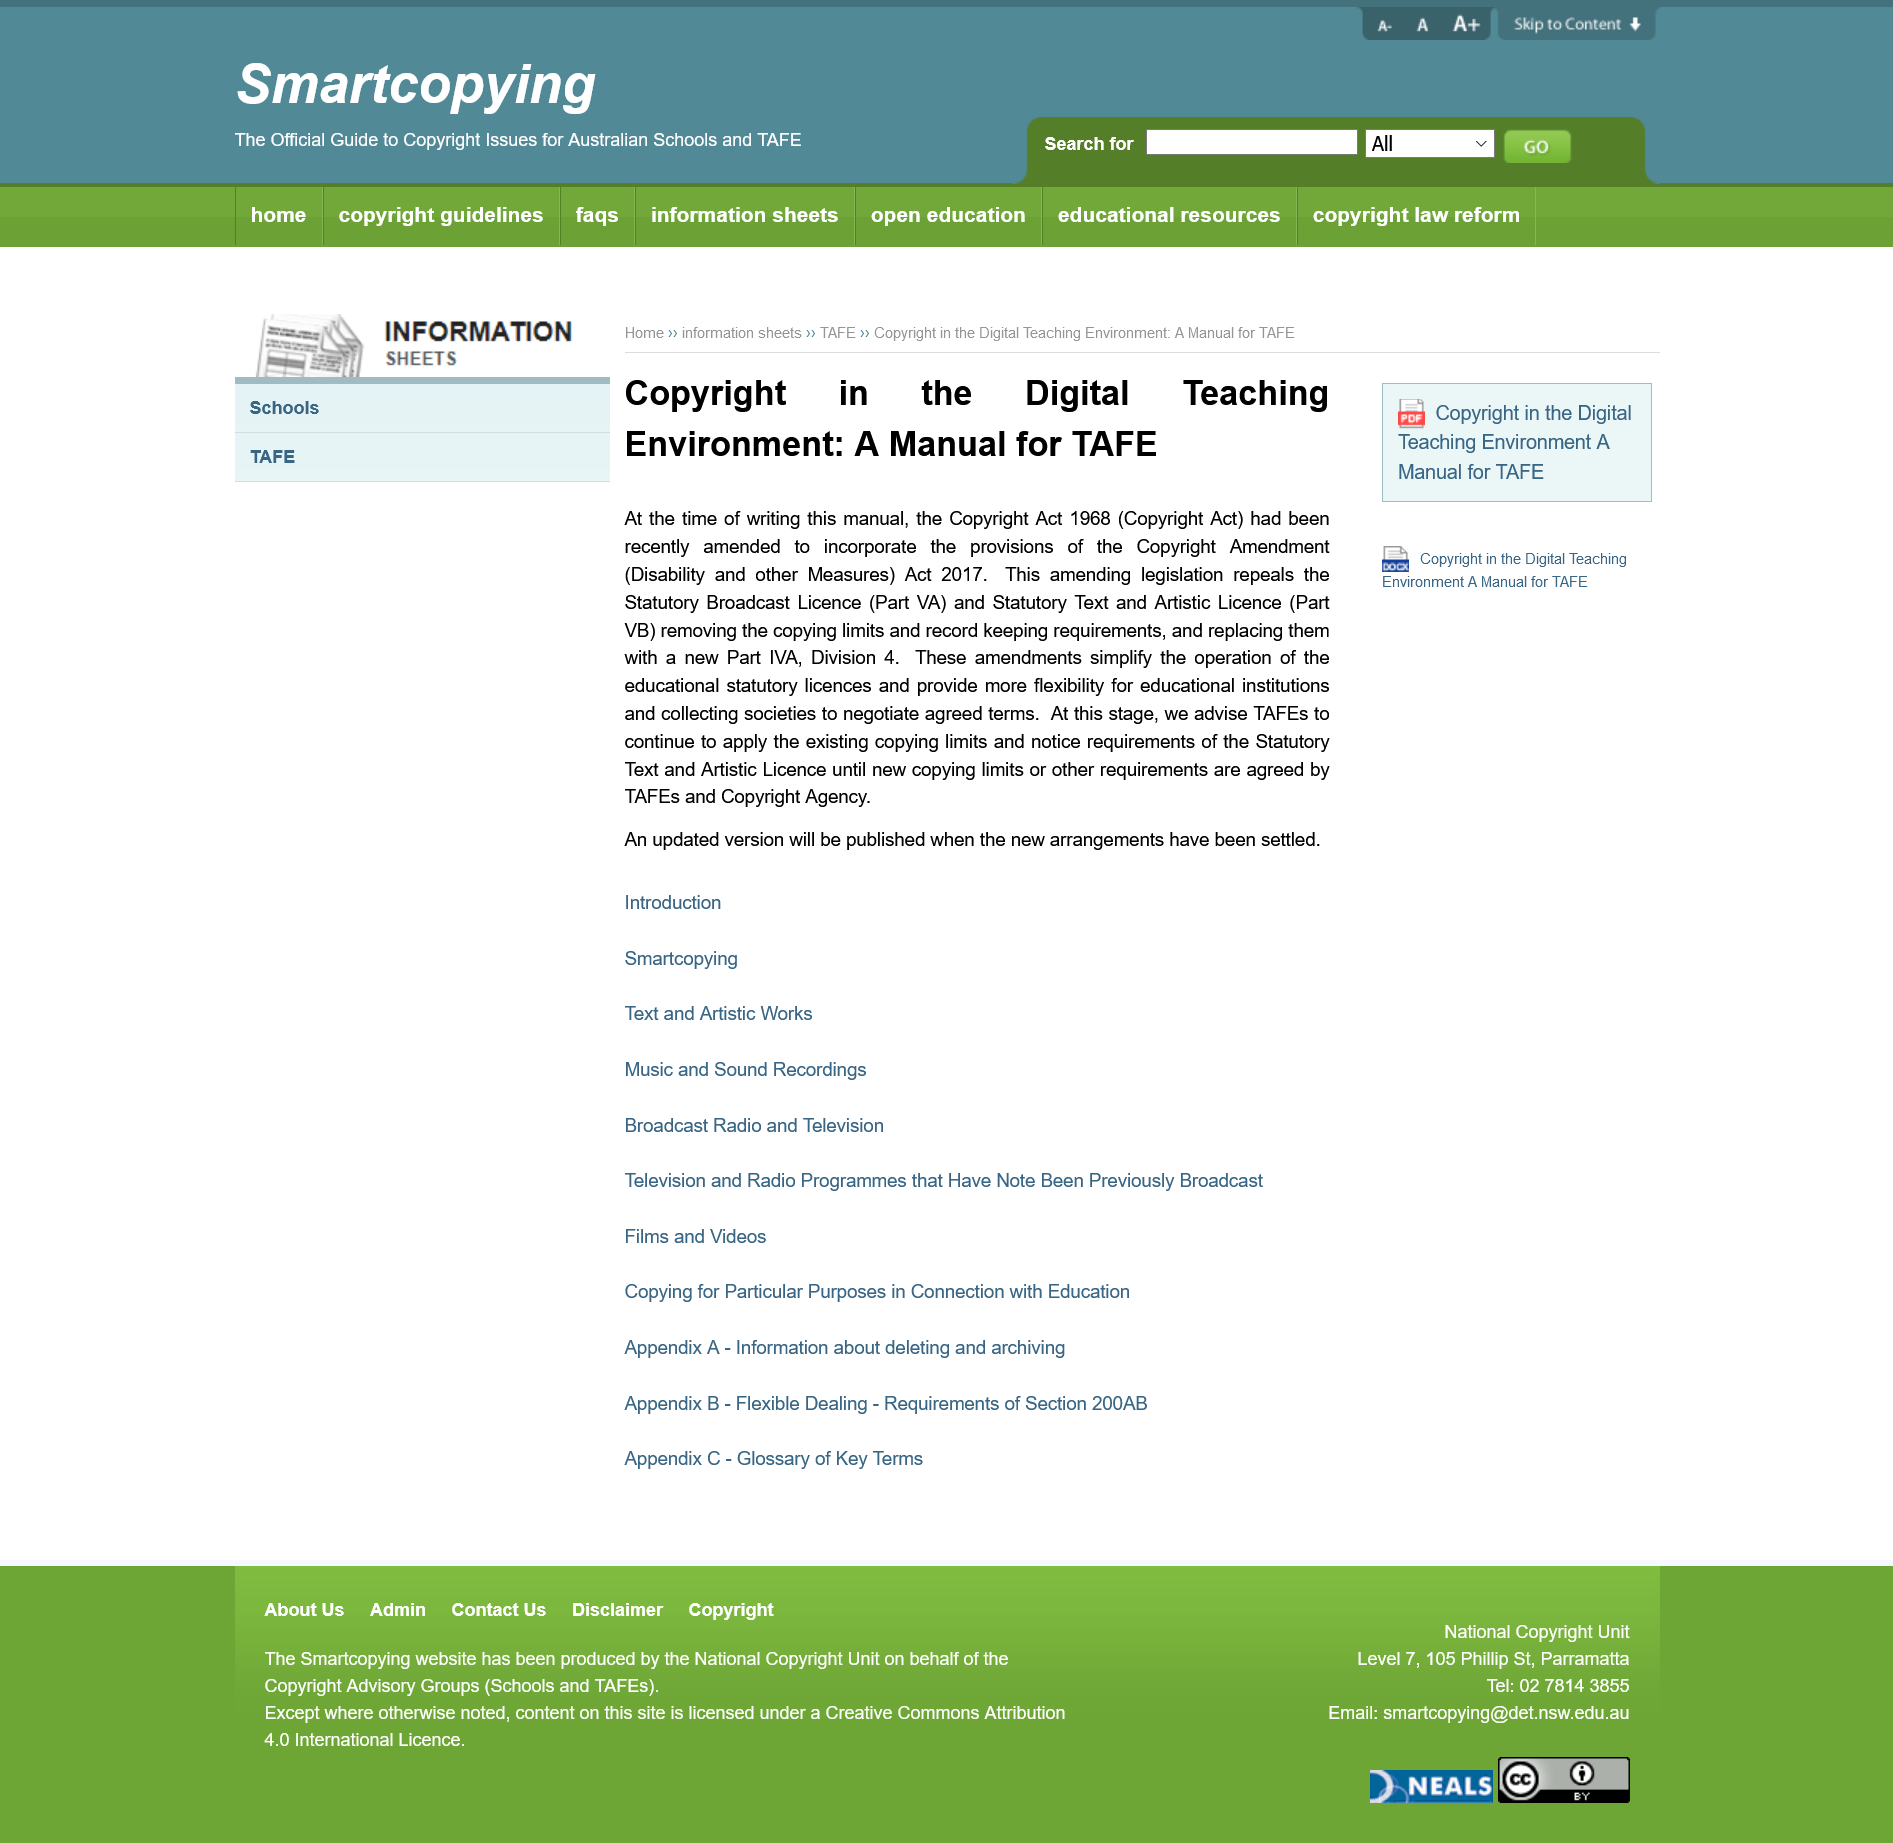List a handful of essential elements in this visual. The amendments simplify the operation of the educational statutory licenses by streamlining the process of obtaining them and reducing the administrative burden on educational institutions. It is determined that once new copying limits or other requirements are agreed upon, an updated version will be published by TAFEs and Copyright Agency, and TAFEs will be responsible for this decision. The Copyright Act 1968 had recently been amended to include the provisions of the Copyright Amendment (Disability and other measures) Act 2017 in order to incorporate the amendments made by that act. 